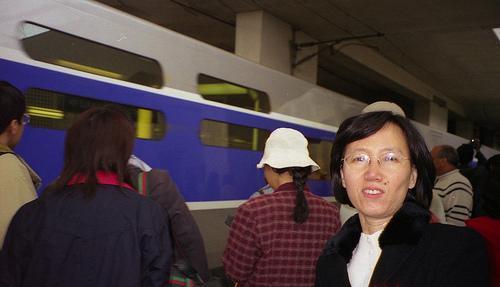How many people are looking at the camera?
Give a very brief answer. 1. How many people are wearing glasses?
Give a very brief answer. 1. 